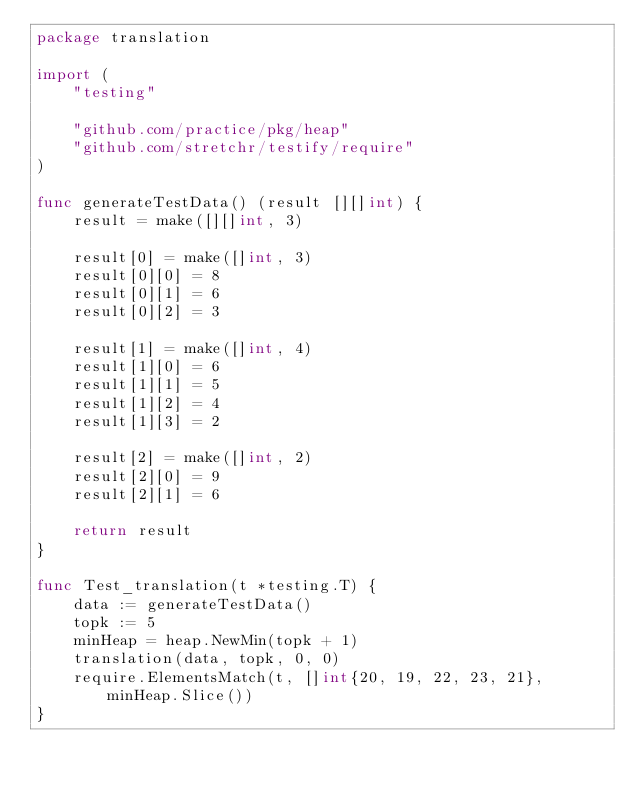<code> <loc_0><loc_0><loc_500><loc_500><_Go_>package translation

import (
	"testing"

	"github.com/practice/pkg/heap"
	"github.com/stretchr/testify/require"
)

func generateTestData() (result [][]int) {
	result = make([][]int, 3)

	result[0] = make([]int, 3)
	result[0][0] = 8
	result[0][1] = 6
	result[0][2] = 3

	result[1] = make([]int, 4)
	result[1][0] = 6
	result[1][1] = 5
	result[1][2] = 4
	result[1][3] = 2

	result[2] = make([]int, 2)
	result[2][0] = 9
	result[2][1] = 6

	return result
}

func Test_translation(t *testing.T) {
	data := generateTestData()
	topk := 5
	minHeap = heap.NewMin(topk + 1)
	translation(data, topk, 0, 0)
	require.ElementsMatch(t, []int{20, 19, 22, 23, 21}, minHeap.Slice())
}
</code> 